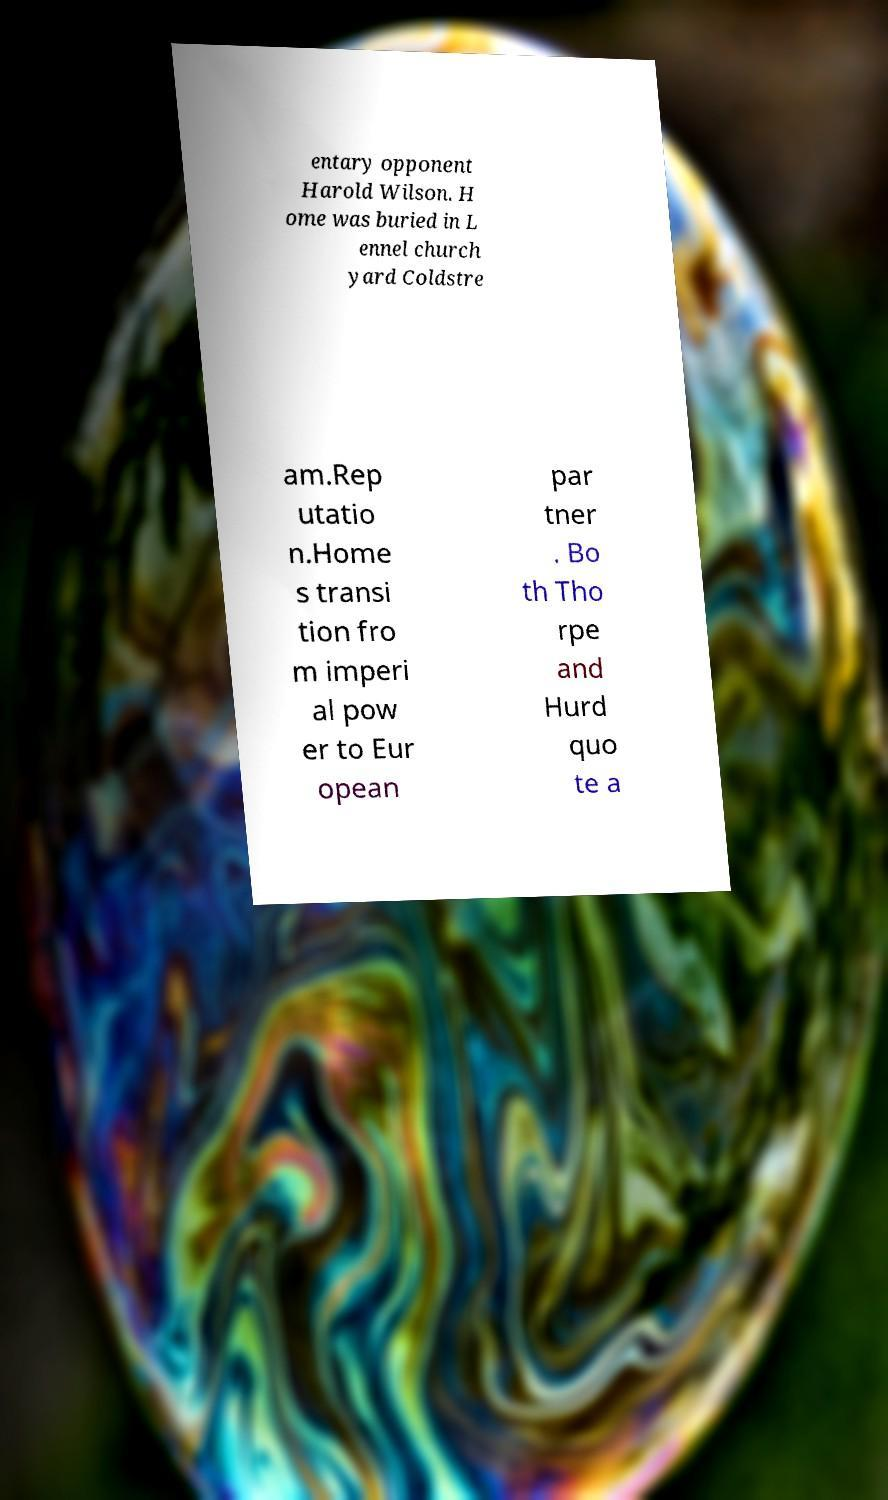For documentation purposes, I need the text within this image transcribed. Could you provide that? entary opponent Harold Wilson. H ome was buried in L ennel church yard Coldstre am.Rep utatio n.Home s transi tion fro m imperi al pow er to Eur opean par tner . Bo th Tho rpe and Hurd quo te a 